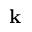<formula> <loc_0><loc_0><loc_500><loc_500>k</formula> 